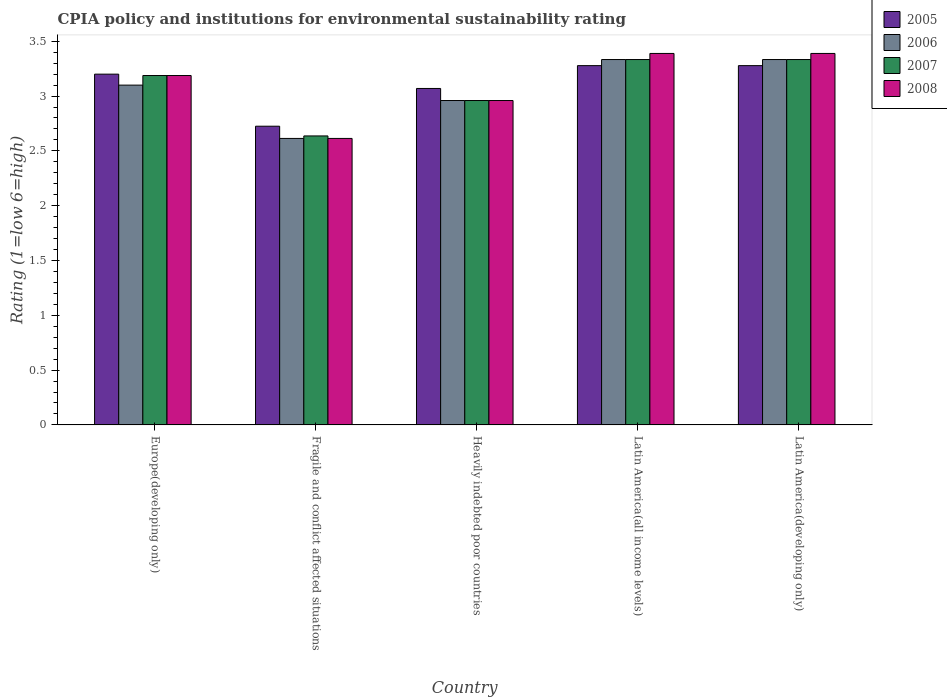How many different coloured bars are there?
Give a very brief answer. 4. How many groups of bars are there?
Offer a terse response. 5. Are the number of bars on each tick of the X-axis equal?
Your response must be concise. Yes. How many bars are there on the 1st tick from the right?
Provide a succinct answer. 4. What is the label of the 5th group of bars from the left?
Make the answer very short. Latin America(developing only). What is the CPIA rating in 2007 in Latin America(all income levels)?
Ensure brevity in your answer.  3.33. Across all countries, what is the maximum CPIA rating in 2005?
Provide a succinct answer. 3.28. Across all countries, what is the minimum CPIA rating in 2007?
Keep it short and to the point. 2.64. In which country was the CPIA rating in 2006 maximum?
Your answer should be compact. Latin America(all income levels). In which country was the CPIA rating in 2005 minimum?
Ensure brevity in your answer.  Fragile and conflict affected situations. What is the total CPIA rating in 2006 in the graph?
Your answer should be very brief. 15.34. What is the difference between the CPIA rating in 2005 in Fragile and conflict affected situations and the CPIA rating in 2006 in Heavily indebted poor countries?
Provide a succinct answer. -0.23. What is the average CPIA rating in 2008 per country?
Give a very brief answer. 3.11. What is the difference between the CPIA rating of/in 2008 and CPIA rating of/in 2007 in Fragile and conflict affected situations?
Your answer should be very brief. -0.02. What is the ratio of the CPIA rating in 2007 in Fragile and conflict affected situations to that in Latin America(all income levels)?
Your answer should be compact. 0.79. Is the CPIA rating in 2008 in Fragile and conflict affected situations less than that in Latin America(developing only)?
Provide a succinct answer. Yes. What is the difference between the highest and the second highest CPIA rating in 2005?
Offer a terse response. -0.08. What is the difference between the highest and the lowest CPIA rating in 2007?
Keep it short and to the point. 0.7. What does the 1st bar from the right in Latin America(developing only) represents?
Ensure brevity in your answer.  2008. Is it the case that in every country, the sum of the CPIA rating in 2006 and CPIA rating in 2008 is greater than the CPIA rating in 2005?
Your response must be concise. Yes. How many bars are there?
Offer a very short reply. 20. Are all the bars in the graph horizontal?
Ensure brevity in your answer.  No. What is the difference between two consecutive major ticks on the Y-axis?
Your answer should be very brief. 0.5. Where does the legend appear in the graph?
Make the answer very short. Top right. How many legend labels are there?
Give a very brief answer. 4. What is the title of the graph?
Provide a short and direct response. CPIA policy and institutions for environmental sustainability rating. What is the label or title of the X-axis?
Give a very brief answer. Country. What is the label or title of the Y-axis?
Provide a short and direct response. Rating (1=low 6=high). What is the Rating (1=low 6=high) in 2006 in Europe(developing only)?
Provide a succinct answer. 3.1. What is the Rating (1=low 6=high) of 2007 in Europe(developing only)?
Your response must be concise. 3.19. What is the Rating (1=low 6=high) of 2008 in Europe(developing only)?
Offer a very short reply. 3.19. What is the Rating (1=low 6=high) in 2005 in Fragile and conflict affected situations?
Provide a short and direct response. 2.73. What is the Rating (1=low 6=high) of 2006 in Fragile and conflict affected situations?
Provide a short and direct response. 2.61. What is the Rating (1=low 6=high) in 2007 in Fragile and conflict affected situations?
Your answer should be very brief. 2.64. What is the Rating (1=low 6=high) of 2008 in Fragile and conflict affected situations?
Ensure brevity in your answer.  2.61. What is the Rating (1=low 6=high) of 2005 in Heavily indebted poor countries?
Your answer should be very brief. 3.07. What is the Rating (1=low 6=high) in 2006 in Heavily indebted poor countries?
Ensure brevity in your answer.  2.96. What is the Rating (1=low 6=high) of 2007 in Heavily indebted poor countries?
Keep it short and to the point. 2.96. What is the Rating (1=low 6=high) in 2008 in Heavily indebted poor countries?
Make the answer very short. 2.96. What is the Rating (1=low 6=high) of 2005 in Latin America(all income levels)?
Your response must be concise. 3.28. What is the Rating (1=low 6=high) of 2006 in Latin America(all income levels)?
Ensure brevity in your answer.  3.33. What is the Rating (1=low 6=high) in 2007 in Latin America(all income levels)?
Provide a short and direct response. 3.33. What is the Rating (1=low 6=high) in 2008 in Latin America(all income levels)?
Your answer should be very brief. 3.39. What is the Rating (1=low 6=high) in 2005 in Latin America(developing only)?
Provide a succinct answer. 3.28. What is the Rating (1=low 6=high) of 2006 in Latin America(developing only)?
Provide a succinct answer. 3.33. What is the Rating (1=low 6=high) of 2007 in Latin America(developing only)?
Provide a succinct answer. 3.33. What is the Rating (1=low 6=high) of 2008 in Latin America(developing only)?
Provide a succinct answer. 3.39. Across all countries, what is the maximum Rating (1=low 6=high) of 2005?
Ensure brevity in your answer.  3.28. Across all countries, what is the maximum Rating (1=low 6=high) in 2006?
Keep it short and to the point. 3.33. Across all countries, what is the maximum Rating (1=low 6=high) of 2007?
Your response must be concise. 3.33. Across all countries, what is the maximum Rating (1=low 6=high) of 2008?
Offer a terse response. 3.39. Across all countries, what is the minimum Rating (1=low 6=high) in 2005?
Provide a short and direct response. 2.73. Across all countries, what is the minimum Rating (1=low 6=high) of 2006?
Offer a very short reply. 2.61. Across all countries, what is the minimum Rating (1=low 6=high) in 2007?
Your answer should be compact. 2.64. Across all countries, what is the minimum Rating (1=low 6=high) in 2008?
Provide a succinct answer. 2.61. What is the total Rating (1=low 6=high) in 2005 in the graph?
Your answer should be very brief. 15.55. What is the total Rating (1=low 6=high) of 2006 in the graph?
Your answer should be compact. 15.34. What is the total Rating (1=low 6=high) in 2007 in the graph?
Your answer should be very brief. 15.45. What is the total Rating (1=low 6=high) in 2008 in the graph?
Offer a terse response. 15.54. What is the difference between the Rating (1=low 6=high) of 2005 in Europe(developing only) and that in Fragile and conflict affected situations?
Your response must be concise. 0.47. What is the difference between the Rating (1=low 6=high) in 2006 in Europe(developing only) and that in Fragile and conflict affected situations?
Give a very brief answer. 0.49. What is the difference between the Rating (1=low 6=high) in 2007 in Europe(developing only) and that in Fragile and conflict affected situations?
Provide a succinct answer. 0.55. What is the difference between the Rating (1=low 6=high) of 2008 in Europe(developing only) and that in Fragile and conflict affected situations?
Keep it short and to the point. 0.57. What is the difference between the Rating (1=low 6=high) in 2005 in Europe(developing only) and that in Heavily indebted poor countries?
Keep it short and to the point. 0.13. What is the difference between the Rating (1=low 6=high) of 2006 in Europe(developing only) and that in Heavily indebted poor countries?
Make the answer very short. 0.14. What is the difference between the Rating (1=low 6=high) in 2007 in Europe(developing only) and that in Heavily indebted poor countries?
Your answer should be compact. 0.23. What is the difference between the Rating (1=low 6=high) of 2008 in Europe(developing only) and that in Heavily indebted poor countries?
Make the answer very short. 0.23. What is the difference between the Rating (1=low 6=high) in 2005 in Europe(developing only) and that in Latin America(all income levels)?
Provide a succinct answer. -0.08. What is the difference between the Rating (1=low 6=high) of 2006 in Europe(developing only) and that in Latin America(all income levels)?
Give a very brief answer. -0.23. What is the difference between the Rating (1=low 6=high) in 2007 in Europe(developing only) and that in Latin America(all income levels)?
Keep it short and to the point. -0.15. What is the difference between the Rating (1=low 6=high) of 2008 in Europe(developing only) and that in Latin America(all income levels)?
Your answer should be compact. -0.2. What is the difference between the Rating (1=low 6=high) in 2005 in Europe(developing only) and that in Latin America(developing only)?
Provide a short and direct response. -0.08. What is the difference between the Rating (1=low 6=high) of 2006 in Europe(developing only) and that in Latin America(developing only)?
Provide a succinct answer. -0.23. What is the difference between the Rating (1=low 6=high) of 2007 in Europe(developing only) and that in Latin America(developing only)?
Make the answer very short. -0.15. What is the difference between the Rating (1=low 6=high) of 2008 in Europe(developing only) and that in Latin America(developing only)?
Your answer should be compact. -0.2. What is the difference between the Rating (1=low 6=high) of 2005 in Fragile and conflict affected situations and that in Heavily indebted poor countries?
Your response must be concise. -0.34. What is the difference between the Rating (1=low 6=high) in 2006 in Fragile and conflict affected situations and that in Heavily indebted poor countries?
Offer a very short reply. -0.35. What is the difference between the Rating (1=low 6=high) in 2007 in Fragile and conflict affected situations and that in Heavily indebted poor countries?
Give a very brief answer. -0.32. What is the difference between the Rating (1=low 6=high) of 2008 in Fragile and conflict affected situations and that in Heavily indebted poor countries?
Offer a terse response. -0.35. What is the difference between the Rating (1=low 6=high) of 2005 in Fragile and conflict affected situations and that in Latin America(all income levels)?
Provide a succinct answer. -0.55. What is the difference between the Rating (1=low 6=high) of 2006 in Fragile and conflict affected situations and that in Latin America(all income levels)?
Give a very brief answer. -0.72. What is the difference between the Rating (1=low 6=high) of 2007 in Fragile and conflict affected situations and that in Latin America(all income levels)?
Ensure brevity in your answer.  -0.7. What is the difference between the Rating (1=low 6=high) of 2008 in Fragile and conflict affected situations and that in Latin America(all income levels)?
Offer a terse response. -0.78. What is the difference between the Rating (1=low 6=high) of 2005 in Fragile and conflict affected situations and that in Latin America(developing only)?
Make the answer very short. -0.55. What is the difference between the Rating (1=low 6=high) in 2006 in Fragile and conflict affected situations and that in Latin America(developing only)?
Provide a short and direct response. -0.72. What is the difference between the Rating (1=low 6=high) in 2007 in Fragile and conflict affected situations and that in Latin America(developing only)?
Offer a very short reply. -0.7. What is the difference between the Rating (1=low 6=high) in 2008 in Fragile and conflict affected situations and that in Latin America(developing only)?
Ensure brevity in your answer.  -0.78. What is the difference between the Rating (1=low 6=high) of 2005 in Heavily indebted poor countries and that in Latin America(all income levels)?
Provide a short and direct response. -0.21. What is the difference between the Rating (1=low 6=high) of 2006 in Heavily indebted poor countries and that in Latin America(all income levels)?
Ensure brevity in your answer.  -0.37. What is the difference between the Rating (1=low 6=high) in 2007 in Heavily indebted poor countries and that in Latin America(all income levels)?
Give a very brief answer. -0.37. What is the difference between the Rating (1=low 6=high) of 2008 in Heavily indebted poor countries and that in Latin America(all income levels)?
Your answer should be compact. -0.43. What is the difference between the Rating (1=low 6=high) of 2005 in Heavily indebted poor countries and that in Latin America(developing only)?
Provide a succinct answer. -0.21. What is the difference between the Rating (1=low 6=high) in 2006 in Heavily indebted poor countries and that in Latin America(developing only)?
Offer a terse response. -0.37. What is the difference between the Rating (1=low 6=high) of 2007 in Heavily indebted poor countries and that in Latin America(developing only)?
Keep it short and to the point. -0.37. What is the difference between the Rating (1=low 6=high) of 2008 in Heavily indebted poor countries and that in Latin America(developing only)?
Offer a terse response. -0.43. What is the difference between the Rating (1=low 6=high) of 2007 in Latin America(all income levels) and that in Latin America(developing only)?
Keep it short and to the point. 0. What is the difference between the Rating (1=low 6=high) of 2008 in Latin America(all income levels) and that in Latin America(developing only)?
Keep it short and to the point. 0. What is the difference between the Rating (1=low 6=high) in 2005 in Europe(developing only) and the Rating (1=low 6=high) in 2006 in Fragile and conflict affected situations?
Your answer should be very brief. 0.59. What is the difference between the Rating (1=low 6=high) in 2005 in Europe(developing only) and the Rating (1=low 6=high) in 2007 in Fragile and conflict affected situations?
Your response must be concise. 0.56. What is the difference between the Rating (1=low 6=high) of 2005 in Europe(developing only) and the Rating (1=low 6=high) of 2008 in Fragile and conflict affected situations?
Offer a very short reply. 0.59. What is the difference between the Rating (1=low 6=high) of 2006 in Europe(developing only) and the Rating (1=low 6=high) of 2007 in Fragile and conflict affected situations?
Provide a succinct answer. 0.46. What is the difference between the Rating (1=low 6=high) in 2006 in Europe(developing only) and the Rating (1=low 6=high) in 2008 in Fragile and conflict affected situations?
Your answer should be compact. 0.49. What is the difference between the Rating (1=low 6=high) of 2007 in Europe(developing only) and the Rating (1=low 6=high) of 2008 in Fragile and conflict affected situations?
Your answer should be very brief. 0.57. What is the difference between the Rating (1=low 6=high) in 2005 in Europe(developing only) and the Rating (1=low 6=high) in 2006 in Heavily indebted poor countries?
Keep it short and to the point. 0.24. What is the difference between the Rating (1=low 6=high) of 2005 in Europe(developing only) and the Rating (1=low 6=high) of 2007 in Heavily indebted poor countries?
Make the answer very short. 0.24. What is the difference between the Rating (1=low 6=high) of 2005 in Europe(developing only) and the Rating (1=low 6=high) of 2008 in Heavily indebted poor countries?
Offer a terse response. 0.24. What is the difference between the Rating (1=low 6=high) in 2006 in Europe(developing only) and the Rating (1=low 6=high) in 2007 in Heavily indebted poor countries?
Your answer should be very brief. 0.14. What is the difference between the Rating (1=low 6=high) in 2006 in Europe(developing only) and the Rating (1=low 6=high) in 2008 in Heavily indebted poor countries?
Give a very brief answer. 0.14. What is the difference between the Rating (1=low 6=high) in 2007 in Europe(developing only) and the Rating (1=low 6=high) in 2008 in Heavily indebted poor countries?
Your response must be concise. 0.23. What is the difference between the Rating (1=low 6=high) of 2005 in Europe(developing only) and the Rating (1=low 6=high) of 2006 in Latin America(all income levels)?
Your response must be concise. -0.13. What is the difference between the Rating (1=low 6=high) in 2005 in Europe(developing only) and the Rating (1=low 6=high) in 2007 in Latin America(all income levels)?
Offer a terse response. -0.13. What is the difference between the Rating (1=low 6=high) in 2005 in Europe(developing only) and the Rating (1=low 6=high) in 2008 in Latin America(all income levels)?
Provide a short and direct response. -0.19. What is the difference between the Rating (1=low 6=high) of 2006 in Europe(developing only) and the Rating (1=low 6=high) of 2007 in Latin America(all income levels)?
Offer a terse response. -0.23. What is the difference between the Rating (1=low 6=high) of 2006 in Europe(developing only) and the Rating (1=low 6=high) of 2008 in Latin America(all income levels)?
Provide a succinct answer. -0.29. What is the difference between the Rating (1=low 6=high) of 2007 in Europe(developing only) and the Rating (1=low 6=high) of 2008 in Latin America(all income levels)?
Your response must be concise. -0.2. What is the difference between the Rating (1=low 6=high) of 2005 in Europe(developing only) and the Rating (1=low 6=high) of 2006 in Latin America(developing only)?
Offer a very short reply. -0.13. What is the difference between the Rating (1=low 6=high) of 2005 in Europe(developing only) and the Rating (1=low 6=high) of 2007 in Latin America(developing only)?
Offer a very short reply. -0.13. What is the difference between the Rating (1=low 6=high) in 2005 in Europe(developing only) and the Rating (1=low 6=high) in 2008 in Latin America(developing only)?
Offer a very short reply. -0.19. What is the difference between the Rating (1=low 6=high) of 2006 in Europe(developing only) and the Rating (1=low 6=high) of 2007 in Latin America(developing only)?
Your response must be concise. -0.23. What is the difference between the Rating (1=low 6=high) of 2006 in Europe(developing only) and the Rating (1=low 6=high) of 2008 in Latin America(developing only)?
Make the answer very short. -0.29. What is the difference between the Rating (1=low 6=high) in 2007 in Europe(developing only) and the Rating (1=low 6=high) in 2008 in Latin America(developing only)?
Your response must be concise. -0.2. What is the difference between the Rating (1=low 6=high) in 2005 in Fragile and conflict affected situations and the Rating (1=low 6=high) in 2006 in Heavily indebted poor countries?
Offer a terse response. -0.23. What is the difference between the Rating (1=low 6=high) in 2005 in Fragile and conflict affected situations and the Rating (1=low 6=high) in 2007 in Heavily indebted poor countries?
Your response must be concise. -0.23. What is the difference between the Rating (1=low 6=high) in 2005 in Fragile and conflict affected situations and the Rating (1=low 6=high) in 2008 in Heavily indebted poor countries?
Your answer should be very brief. -0.23. What is the difference between the Rating (1=low 6=high) of 2006 in Fragile and conflict affected situations and the Rating (1=low 6=high) of 2007 in Heavily indebted poor countries?
Your answer should be very brief. -0.35. What is the difference between the Rating (1=low 6=high) of 2006 in Fragile and conflict affected situations and the Rating (1=low 6=high) of 2008 in Heavily indebted poor countries?
Give a very brief answer. -0.35. What is the difference between the Rating (1=low 6=high) in 2007 in Fragile and conflict affected situations and the Rating (1=low 6=high) in 2008 in Heavily indebted poor countries?
Offer a terse response. -0.32. What is the difference between the Rating (1=low 6=high) in 2005 in Fragile and conflict affected situations and the Rating (1=low 6=high) in 2006 in Latin America(all income levels)?
Your answer should be compact. -0.61. What is the difference between the Rating (1=low 6=high) in 2005 in Fragile and conflict affected situations and the Rating (1=low 6=high) in 2007 in Latin America(all income levels)?
Offer a terse response. -0.61. What is the difference between the Rating (1=low 6=high) of 2005 in Fragile and conflict affected situations and the Rating (1=low 6=high) of 2008 in Latin America(all income levels)?
Your answer should be compact. -0.66. What is the difference between the Rating (1=low 6=high) of 2006 in Fragile and conflict affected situations and the Rating (1=low 6=high) of 2007 in Latin America(all income levels)?
Provide a succinct answer. -0.72. What is the difference between the Rating (1=low 6=high) in 2006 in Fragile and conflict affected situations and the Rating (1=low 6=high) in 2008 in Latin America(all income levels)?
Your response must be concise. -0.78. What is the difference between the Rating (1=low 6=high) of 2007 in Fragile and conflict affected situations and the Rating (1=low 6=high) of 2008 in Latin America(all income levels)?
Provide a succinct answer. -0.75. What is the difference between the Rating (1=low 6=high) of 2005 in Fragile and conflict affected situations and the Rating (1=low 6=high) of 2006 in Latin America(developing only)?
Keep it short and to the point. -0.61. What is the difference between the Rating (1=low 6=high) of 2005 in Fragile and conflict affected situations and the Rating (1=low 6=high) of 2007 in Latin America(developing only)?
Your answer should be compact. -0.61. What is the difference between the Rating (1=low 6=high) of 2005 in Fragile and conflict affected situations and the Rating (1=low 6=high) of 2008 in Latin America(developing only)?
Make the answer very short. -0.66. What is the difference between the Rating (1=low 6=high) in 2006 in Fragile and conflict affected situations and the Rating (1=low 6=high) in 2007 in Latin America(developing only)?
Keep it short and to the point. -0.72. What is the difference between the Rating (1=low 6=high) in 2006 in Fragile and conflict affected situations and the Rating (1=low 6=high) in 2008 in Latin America(developing only)?
Offer a terse response. -0.78. What is the difference between the Rating (1=low 6=high) of 2007 in Fragile and conflict affected situations and the Rating (1=low 6=high) of 2008 in Latin America(developing only)?
Provide a short and direct response. -0.75. What is the difference between the Rating (1=low 6=high) of 2005 in Heavily indebted poor countries and the Rating (1=low 6=high) of 2006 in Latin America(all income levels)?
Provide a succinct answer. -0.26. What is the difference between the Rating (1=low 6=high) of 2005 in Heavily indebted poor countries and the Rating (1=low 6=high) of 2007 in Latin America(all income levels)?
Make the answer very short. -0.26. What is the difference between the Rating (1=low 6=high) of 2005 in Heavily indebted poor countries and the Rating (1=low 6=high) of 2008 in Latin America(all income levels)?
Ensure brevity in your answer.  -0.32. What is the difference between the Rating (1=low 6=high) of 2006 in Heavily indebted poor countries and the Rating (1=low 6=high) of 2007 in Latin America(all income levels)?
Make the answer very short. -0.37. What is the difference between the Rating (1=low 6=high) of 2006 in Heavily indebted poor countries and the Rating (1=low 6=high) of 2008 in Latin America(all income levels)?
Your answer should be very brief. -0.43. What is the difference between the Rating (1=low 6=high) of 2007 in Heavily indebted poor countries and the Rating (1=low 6=high) of 2008 in Latin America(all income levels)?
Provide a succinct answer. -0.43. What is the difference between the Rating (1=low 6=high) of 2005 in Heavily indebted poor countries and the Rating (1=low 6=high) of 2006 in Latin America(developing only)?
Your answer should be very brief. -0.26. What is the difference between the Rating (1=low 6=high) in 2005 in Heavily indebted poor countries and the Rating (1=low 6=high) in 2007 in Latin America(developing only)?
Your response must be concise. -0.26. What is the difference between the Rating (1=low 6=high) in 2005 in Heavily indebted poor countries and the Rating (1=low 6=high) in 2008 in Latin America(developing only)?
Provide a short and direct response. -0.32. What is the difference between the Rating (1=low 6=high) of 2006 in Heavily indebted poor countries and the Rating (1=low 6=high) of 2007 in Latin America(developing only)?
Your answer should be very brief. -0.37. What is the difference between the Rating (1=low 6=high) of 2006 in Heavily indebted poor countries and the Rating (1=low 6=high) of 2008 in Latin America(developing only)?
Give a very brief answer. -0.43. What is the difference between the Rating (1=low 6=high) of 2007 in Heavily indebted poor countries and the Rating (1=low 6=high) of 2008 in Latin America(developing only)?
Your response must be concise. -0.43. What is the difference between the Rating (1=low 6=high) of 2005 in Latin America(all income levels) and the Rating (1=low 6=high) of 2006 in Latin America(developing only)?
Keep it short and to the point. -0.06. What is the difference between the Rating (1=low 6=high) in 2005 in Latin America(all income levels) and the Rating (1=low 6=high) in 2007 in Latin America(developing only)?
Keep it short and to the point. -0.06. What is the difference between the Rating (1=low 6=high) of 2005 in Latin America(all income levels) and the Rating (1=low 6=high) of 2008 in Latin America(developing only)?
Ensure brevity in your answer.  -0.11. What is the difference between the Rating (1=low 6=high) in 2006 in Latin America(all income levels) and the Rating (1=low 6=high) in 2008 in Latin America(developing only)?
Offer a terse response. -0.06. What is the difference between the Rating (1=low 6=high) in 2007 in Latin America(all income levels) and the Rating (1=low 6=high) in 2008 in Latin America(developing only)?
Provide a succinct answer. -0.06. What is the average Rating (1=low 6=high) in 2005 per country?
Offer a terse response. 3.11. What is the average Rating (1=low 6=high) in 2006 per country?
Give a very brief answer. 3.07. What is the average Rating (1=low 6=high) of 2007 per country?
Offer a very short reply. 3.09. What is the average Rating (1=low 6=high) in 2008 per country?
Make the answer very short. 3.11. What is the difference between the Rating (1=low 6=high) in 2005 and Rating (1=low 6=high) in 2007 in Europe(developing only)?
Keep it short and to the point. 0.01. What is the difference between the Rating (1=low 6=high) of 2005 and Rating (1=low 6=high) of 2008 in Europe(developing only)?
Make the answer very short. 0.01. What is the difference between the Rating (1=low 6=high) of 2006 and Rating (1=low 6=high) of 2007 in Europe(developing only)?
Ensure brevity in your answer.  -0.09. What is the difference between the Rating (1=low 6=high) in 2006 and Rating (1=low 6=high) in 2008 in Europe(developing only)?
Your response must be concise. -0.09. What is the difference between the Rating (1=low 6=high) of 2007 and Rating (1=low 6=high) of 2008 in Europe(developing only)?
Give a very brief answer. 0. What is the difference between the Rating (1=low 6=high) of 2005 and Rating (1=low 6=high) of 2006 in Fragile and conflict affected situations?
Your answer should be compact. 0.11. What is the difference between the Rating (1=low 6=high) in 2005 and Rating (1=low 6=high) in 2007 in Fragile and conflict affected situations?
Your answer should be very brief. 0.09. What is the difference between the Rating (1=low 6=high) of 2005 and Rating (1=low 6=high) of 2008 in Fragile and conflict affected situations?
Your response must be concise. 0.11. What is the difference between the Rating (1=low 6=high) in 2006 and Rating (1=low 6=high) in 2007 in Fragile and conflict affected situations?
Offer a terse response. -0.02. What is the difference between the Rating (1=low 6=high) of 2007 and Rating (1=low 6=high) of 2008 in Fragile and conflict affected situations?
Offer a very short reply. 0.02. What is the difference between the Rating (1=low 6=high) of 2005 and Rating (1=low 6=high) of 2006 in Heavily indebted poor countries?
Offer a very short reply. 0.11. What is the difference between the Rating (1=low 6=high) of 2005 and Rating (1=low 6=high) of 2007 in Heavily indebted poor countries?
Your response must be concise. 0.11. What is the difference between the Rating (1=low 6=high) in 2005 and Rating (1=low 6=high) in 2008 in Heavily indebted poor countries?
Provide a succinct answer. 0.11. What is the difference between the Rating (1=low 6=high) in 2006 and Rating (1=low 6=high) in 2007 in Heavily indebted poor countries?
Your answer should be compact. 0. What is the difference between the Rating (1=low 6=high) of 2006 and Rating (1=low 6=high) of 2008 in Heavily indebted poor countries?
Make the answer very short. 0. What is the difference between the Rating (1=low 6=high) of 2005 and Rating (1=low 6=high) of 2006 in Latin America(all income levels)?
Offer a terse response. -0.06. What is the difference between the Rating (1=low 6=high) in 2005 and Rating (1=low 6=high) in 2007 in Latin America(all income levels)?
Give a very brief answer. -0.06. What is the difference between the Rating (1=low 6=high) of 2005 and Rating (1=low 6=high) of 2008 in Latin America(all income levels)?
Ensure brevity in your answer.  -0.11. What is the difference between the Rating (1=low 6=high) of 2006 and Rating (1=low 6=high) of 2008 in Latin America(all income levels)?
Ensure brevity in your answer.  -0.06. What is the difference between the Rating (1=low 6=high) of 2007 and Rating (1=low 6=high) of 2008 in Latin America(all income levels)?
Ensure brevity in your answer.  -0.06. What is the difference between the Rating (1=low 6=high) of 2005 and Rating (1=low 6=high) of 2006 in Latin America(developing only)?
Give a very brief answer. -0.06. What is the difference between the Rating (1=low 6=high) of 2005 and Rating (1=low 6=high) of 2007 in Latin America(developing only)?
Your answer should be very brief. -0.06. What is the difference between the Rating (1=low 6=high) of 2005 and Rating (1=low 6=high) of 2008 in Latin America(developing only)?
Your answer should be compact. -0.11. What is the difference between the Rating (1=low 6=high) in 2006 and Rating (1=low 6=high) in 2007 in Latin America(developing only)?
Your response must be concise. 0. What is the difference between the Rating (1=low 6=high) of 2006 and Rating (1=low 6=high) of 2008 in Latin America(developing only)?
Your answer should be compact. -0.06. What is the difference between the Rating (1=low 6=high) of 2007 and Rating (1=low 6=high) of 2008 in Latin America(developing only)?
Ensure brevity in your answer.  -0.06. What is the ratio of the Rating (1=low 6=high) of 2005 in Europe(developing only) to that in Fragile and conflict affected situations?
Provide a succinct answer. 1.17. What is the ratio of the Rating (1=low 6=high) in 2006 in Europe(developing only) to that in Fragile and conflict affected situations?
Your answer should be compact. 1.19. What is the ratio of the Rating (1=low 6=high) in 2007 in Europe(developing only) to that in Fragile and conflict affected situations?
Provide a short and direct response. 1.21. What is the ratio of the Rating (1=low 6=high) of 2008 in Europe(developing only) to that in Fragile and conflict affected situations?
Provide a short and direct response. 1.22. What is the ratio of the Rating (1=low 6=high) of 2005 in Europe(developing only) to that in Heavily indebted poor countries?
Keep it short and to the point. 1.04. What is the ratio of the Rating (1=low 6=high) in 2006 in Europe(developing only) to that in Heavily indebted poor countries?
Give a very brief answer. 1.05. What is the ratio of the Rating (1=low 6=high) in 2007 in Europe(developing only) to that in Heavily indebted poor countries?
Your response must be concise. 1.08. What is the ratio of the Rating (1=low 6=high) of 2008 in Europe(developing only) to that in Heavily indebted poor countries?
Provide a succinct answer. 1.08. What is the ratio of the Rating (1=low 6=high) of 2005 in Europe(developing only) to that in Latin America(all income levels)?
Make the answer very short. 0.98. What is the ratio of the Rating (1=low 6=high) of 2007 in Europe(developing only) to that in Latin America(all income levels)?
Provide a short and direct response. 0.96. What is the ratio of the Rating (1=low 6=high) in 2008 in Europe(developing only) to that in Latin America(all income levels)?
Provide a succinct answer. 0.94. What is the ratio of the Rating (1=low 6=high) of 2005 in Europe(developing only) to that in Latin America(developing only)?
Ensure brevity in your answer.  0.98. What is the ratio of the Rating (1=low 6=high) of 2007 in Europe(developing only) to that in Latin America(developing only)?
Give a very brief answer. 0.96. What is the ratio of the Rating (1=low 6=high) in 2008 in Europe(developing only) to that in Latin America(developing only)?
Make the answer very short. 0.94. What is the ratio of the Rating (1=low 6=high) of 2005 in Fragile and conflict affected situations to that in Heavily indebted poor countries?
Offer a terse response. 0.89. What is the ratio of the Rating (1=low 6=high) of 2006 in Fragile and conflict affected situations to that in Heavily indebted poor countries?
Your answer should be compact. 0.88. What is the ratio of the Rating (1=low 6=high) of 2007 in Fragile and conflict affected situations to that in Heavily indebted poor countries?
Provide a short and direct response. 0.89. What is the ratio of the Rating (1=low 6=high) of 2008 in Fragile and conflict affected situations to that in Heavily indebted poor countries?
Your response must be concise. 0.88. What is the ratio of the Rating (1=low 6=high) of 2005 in Fragile and conflict affected situations to that in Latin America(all income levels)?
Your answer should be compact. 0.83. What is the ratio of the Rating (1=low 6=high) of 2006 in Fragile and conflict affected situations to that in Latin America(all income levels)?
Your answer should be compact. 0.78. What is the ratio of the Rating (1=low 6=high) of 2007 in Fragile and conflict affected situations to that in Latin America(all income levels)?
Keep it short and to the point. 0.79. What is the ratio of the Rating (1=low 6=high) of 2008 in Fragile and conflict affected situations to that in Latin America(all income levels)?
Keep it short and to the point. 0.77. What is the ratio of the Rating (1=low 6=high) in 2005 in Fragile and conflict affected situations to that in Latin America(developing only)?
Keep it short and to the point. 0.83. What is the ratio of the Rating (1=low 6=high) of 2006 in Fragile and conflict affected situations to that in Latin America(developing only)?
Keep it short and to the point. 0.78. What is the ratio of the Rating (1=low 6=high) in 2007 in Fragile and conflict affected situations to that in Latin America(developing only)?
Provide a succinct answer. 0.79. What is the ratio of the Rating (1=low 6=high) of 2008 in Fragile and conflict affected situations to that in Latin America(developing only)?
Offer a terse response. 0.77. What is the ratio of the Rating (1=low 6=high) of 2005 in Heavily indebted poor countries to that in Latin America(all income levels)?
Give a very brief answer. 0.94. What is the ratio of the Rating (1=low 6=high) of 2006 in Heavily indebted poor countries to that in Latin America(all income levels)?
Your answer should be compact. 0.89. What is the ratio of the Rating (1=low 6=high) of 2007 in Heavily indebted poor countries to that in Latin America(all income levels)?
Offer a very short reply. 0.89. What is the ratio of the Rating (1=low 6=high) in 2008 in Heavily indebted poor countries to that in Latin America(all income levels)?
Keep it short and to the point. 0.87. What is the ratio of the Rating (1=low 6=high) of 2005 in Heavily indebted poor countries to that in Latin America(developing only)?
Ensure brevity in your answer.  0.94. What is the ratio of the Rating (1=low 6=high) of 2006 in Heavily indebted poor countries to that in Latin America(developing only)?
Your response must be concise. 0.89. What is the ratio of the Rating (1=low 6=high) of 2007 in Heavily indebted poor countries to that in Latin America(developing only)?
Provide a short and direct response. 0.89. What is the ratio of the Rating (1=low 6=high) of 2008 in Heavily indebted poor countries to that in Latin America(developing only)?
Provide a short and direct response. 0.87. What is the ratio of the Rating (1=low 6=high) of 2005 in Latin America(all income levels) to that in Latin America(developing only)?
Keep it short and to the point. 1. What is the ratio of the Rating (1=low 6=high) of 2006 in Latin America(all income levels) to that in Latin America(developing only)?
Keep it short and to the point. 1. What is the difference between the highest and the lowest Rating (1=low 6=high) of 2005?
Offer a very short reply. 0.55. What is the difference between the highest and the lowest Rating (1=low 6=high) in 2006?
Ensure brevity in your answer.  0.72. What is the difference between the highest and the lowest Rating (1=low 6=high) of 2007?
Give a very brief answer. 0.7. What is the difference between the highest and the lowest Rating (1=low 6=high) in 2008?
Provide a succinct answer. 0.78. 